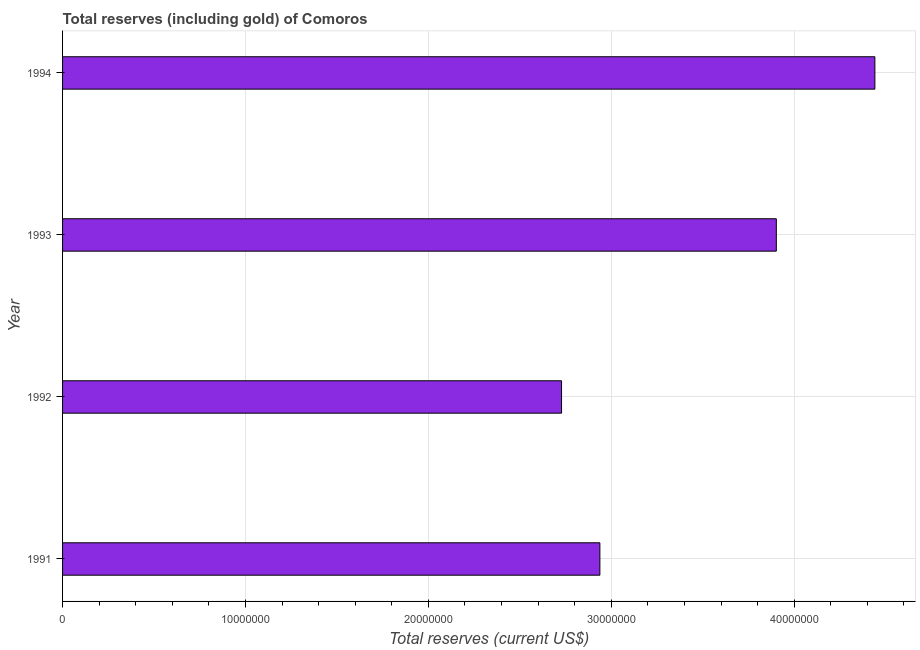Does the graph contain any zero values?
Your response must be concise. No. What is the title of the graph?
Make the answer very short. Total reserves (including gold) of Comoros. What is the label or title of the X-axis?
Provide a short and direct response. Total reserves (current US$). What is the total reserves (including gold) in 1991?
Your answer should be compact. 2.94e+07. Across all years, what is the maximum total reserves (including gold)?
Your answer should be very brief. 4.44e+07. Across all years, what is the minimum total reserves (including gold)?
Give a very brief answer. 2.73e+07. In which year was the total reserves (including gold) maximum?
Your answer should be very brief. 1994. What is the sum of the total reserves (including gold)?
Give a very brief answer. 1.40e+08. What is the difference between the total reserves (including gold) in 1992 and 1993?
Provide a succinct answer. -1.17e+07. What is the average total reserves (including gold) per year?
Offer a very short reply. 3.50e+07. What is the median total reserves (including gold)?
Give a very brief answer. 3.42e+07. In how many years, is the total reserves (including gold) greater than 40000000 US$?
Give a very brief answer. 1. What is the ratio of the total reserves (including gold) in 1991 to that in 1994?
Ensure brevity in your answer.  0.66. What is the difference between the highest and the second highest total reserves (including gold)?
Make the answer very short. 5.39e+06. Is the sum of the total reserves (including gold) in 1993 and 1994 greater than the maximum total reserves (including gold) across all years?
Ensure brevity in your answer.  Yes. What is the difference between the highest and the lowest total reserves (including gold)?
Provide a short and direct response. 1.71e+07. How many years are there in the graph?
Provide a short and direct response. 4. What is the Total reserves (current US$) in 1991?
Make the answer very short. 2.94e+07. What is the Total reserves (current US$) in 1992?
Offer a very short reply. 2.73e+07. What is the Total reserves (current US$) of 1993?
Ensure brevity in your answer.  3.90e+07. What is the Total reserves (current US$) in 1994?
Your answer should be very brief. 4.44e+07. What is the difference between the Total reserves (current US$) in 1991 and 1992?
Your response must be concise. 2.10e+06. What is the difference between the Total reserves (current US$) in 1991 and 1993?
Provide a short and direct response. -9.65e+06. What is the difference between the Total reserves (current US$) in 1991 and 1994?
Your response must be concise. -1.50e+07. What is the difference between the Total reserves (current US$) in 1992 and 1993?
Your response must be concise. -1.17e+07. What is the difference between the Total reserves (current US$) in 1992 and 1994?
Offer a terse response. -1.71e+07. What is the difference between the Total reserves (current US$) in 1993 and 1994?
Your response must be concise. -5.39e+06. What is the ratio of the Total reserves (current US$) in 1991 to that in 1992?
Make the answer very short. 1.08. What is the ratio of the Total reserves (current US$) in 1991 to that in 1993?
Keep it short and to the point. 0.75. What is the ratio of the Total reserves (current US$) in 1991 to that in 1994?
Ensure brevity in your answer.  0.66. What is the ratio of the Total reserves (current US$) in 1992 to that in 1993?
Your answer should be compact. 0.7. What is the ratio of the Total reserves (current US$) in 1992 to that in 1994?
Your answer should be very brief. 0.61. What is the ratio of the Total reserves (current US$) in 1993 to that in 1994?
Ensure brevity in your answer.  0.88. 